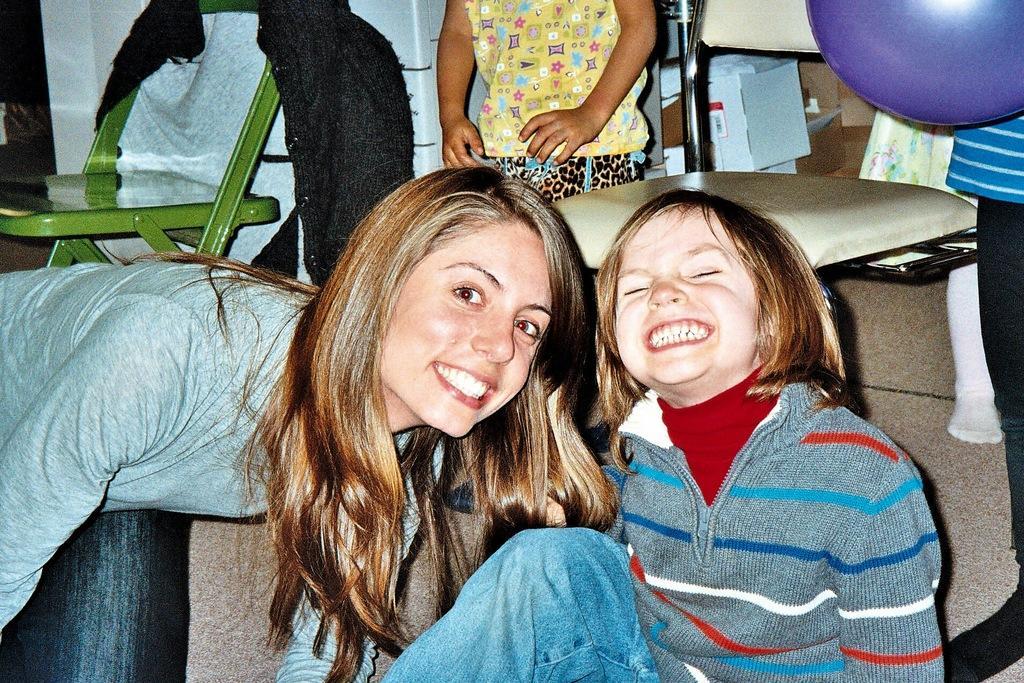Could you give a brief overview of what you see in this image? At the left corner of the image there is a lady with grey jacket is bending and she is smiling. Beside her in the middle of the image there is a girl with a jacket is sitting. Behind them at the left top corner of the image there is a green chair with a jacket on it. And in the background there is a person in yellow dress and also there is a chair. At the right top corner of the image there is a violet balloon holding a person. 